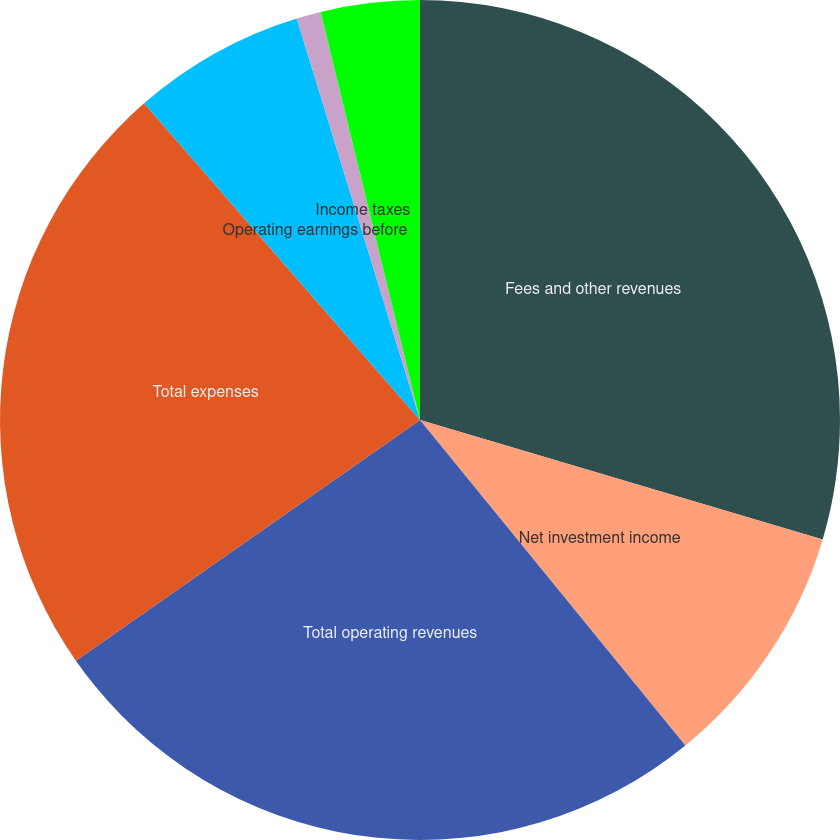Convert chart. <chart><loc_0><loc_0><loc_500><loc_500><pie_chart><fcel>Fees and other revenues<fcel>Net investment income<fcel>Total operating revenues<fcel>Total expenses<fcel>Operating earnings before<fcel>Income taxes<fcel>Operating earnings<nl><fcel>29.59%<fcel>9.53%<fcel>26.17%<fcel>23.31%<fcel>6.67%<fcel>0.94%<fcel>3.8%<nl></chart> 